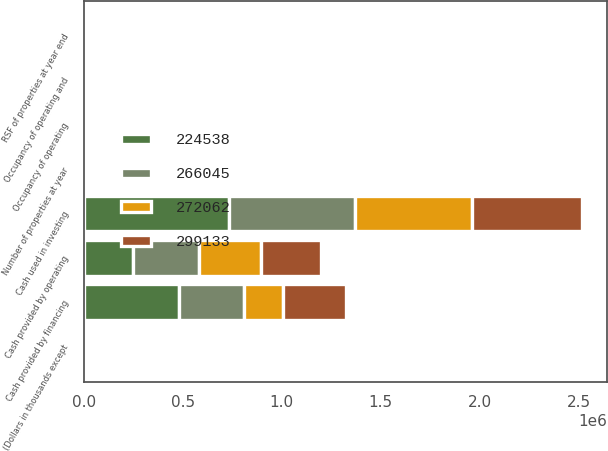<chart> <loc_0><loc_0><loc_500><loc_500><stacked_bar_chart><ecel><fcel>(Dollars in thousands except<fcel>Cash provided by operating<fcel>Cash used in investing<fcel>Cash provided by financing<fcel>Number of properties at year<fcel>RSF of properties at year end<fcel>Occupancy of operating<fcel>Occupancy of operating and<nl><fcel>266045<fcel>2014<fcel>334325<fcel>634829<fcel>331312<fcel>193<fcel>2012.5<fcel>97<fcel>96<nl><fcel>272062<fcel>2013<fcel>312727<fcel>591375<fcel>197570<fcel>184<fcel>2012.5<fcel>96<fcel>96<nl><fcel>299133<fcel>2012<fcel>305533<fcel>558100<fcel>314860<fcel>181<fcel>2012.5<fcel>95<fcel>92<nl><fcel>224538<fcel>2011<fcel>246960<fcel>733579<fcel>479156<fcel>176<fcel>2012.5<fcel>95<fcel>88<nl></chart> 